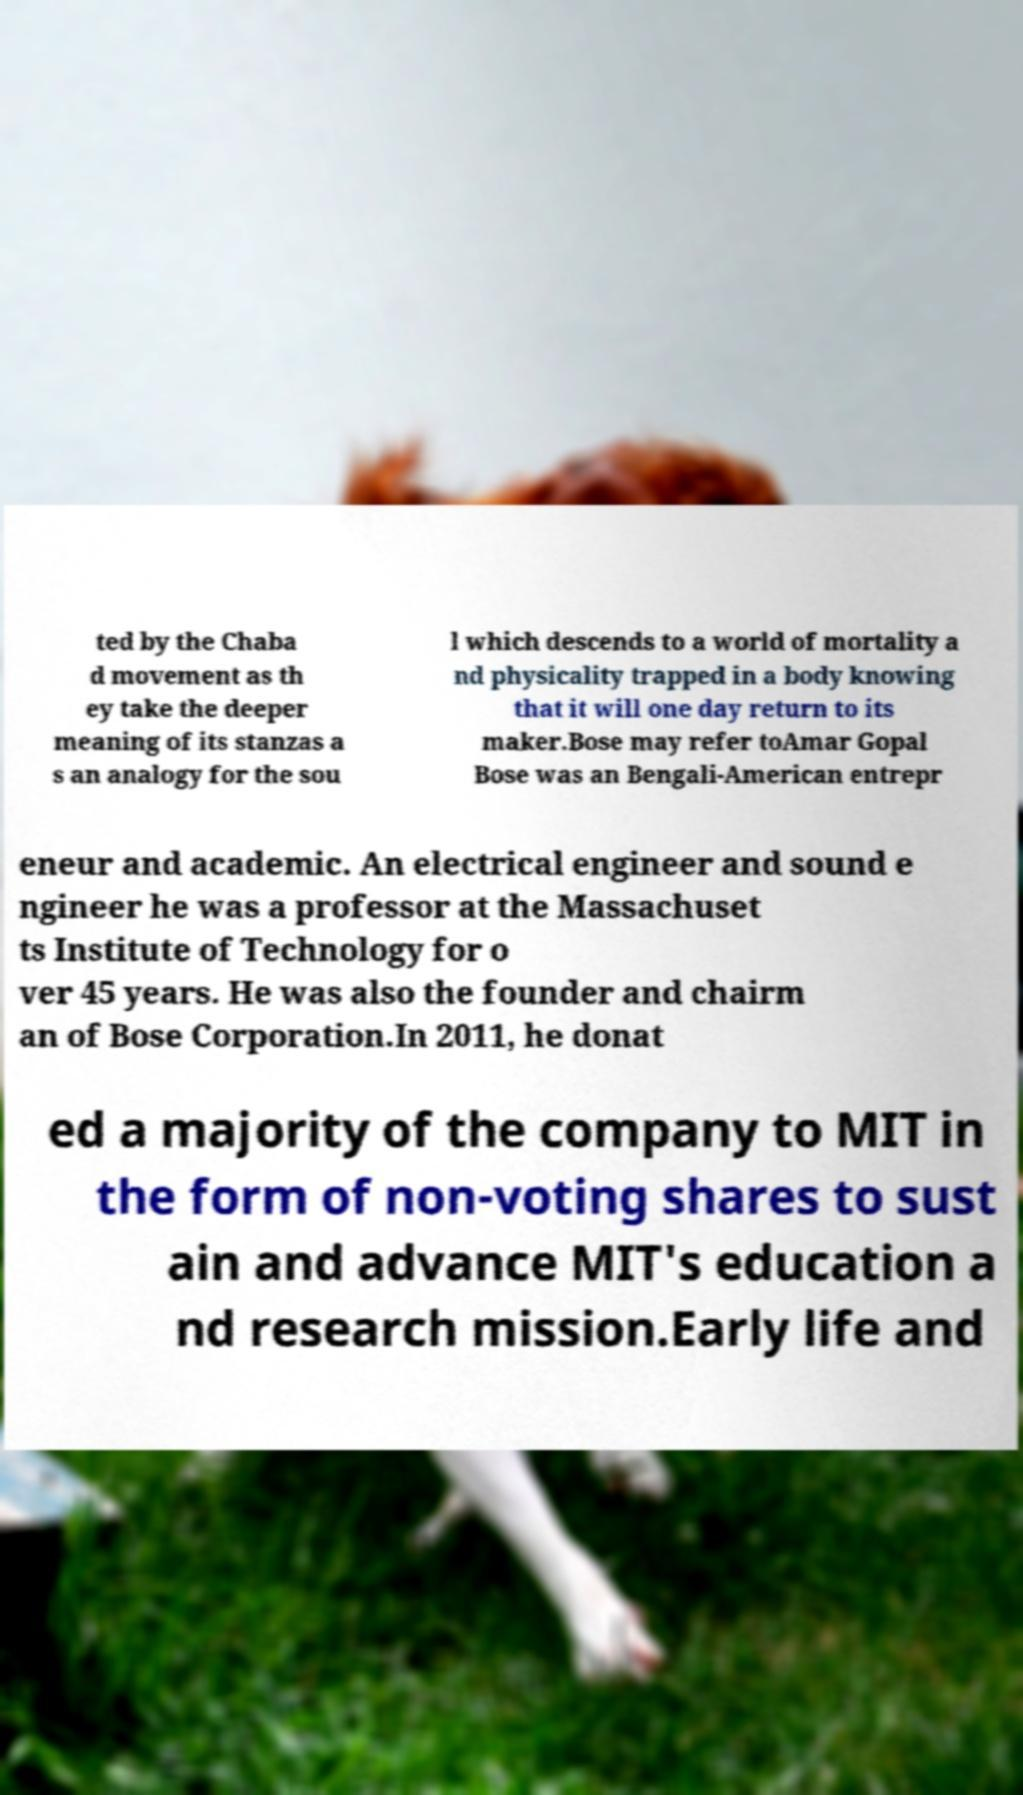Can you accurately transcribe the text from the provided image for me? ted by the Chaba d movement as th ey take the deeper meaning of its stanzas a s an analogy for the sou l which descends to a world of mortality a nd physicality trapped in a body knowing that it will one day return to its maker.Bose may refer toAmar Gopal Bose was an Bengali-American entrepr eneur and academic. An electrical engineer and sound e ngineer he was a professor at the Massachuset ts Institute of Technology for o ver 45 years. He was also the founder and chairm an of Bose Corporation.In 2011, he donat ed a majority of the company to MIT in the form of non-voting shares to sust ain and advance MIT's education a nd research mission.Early life and 